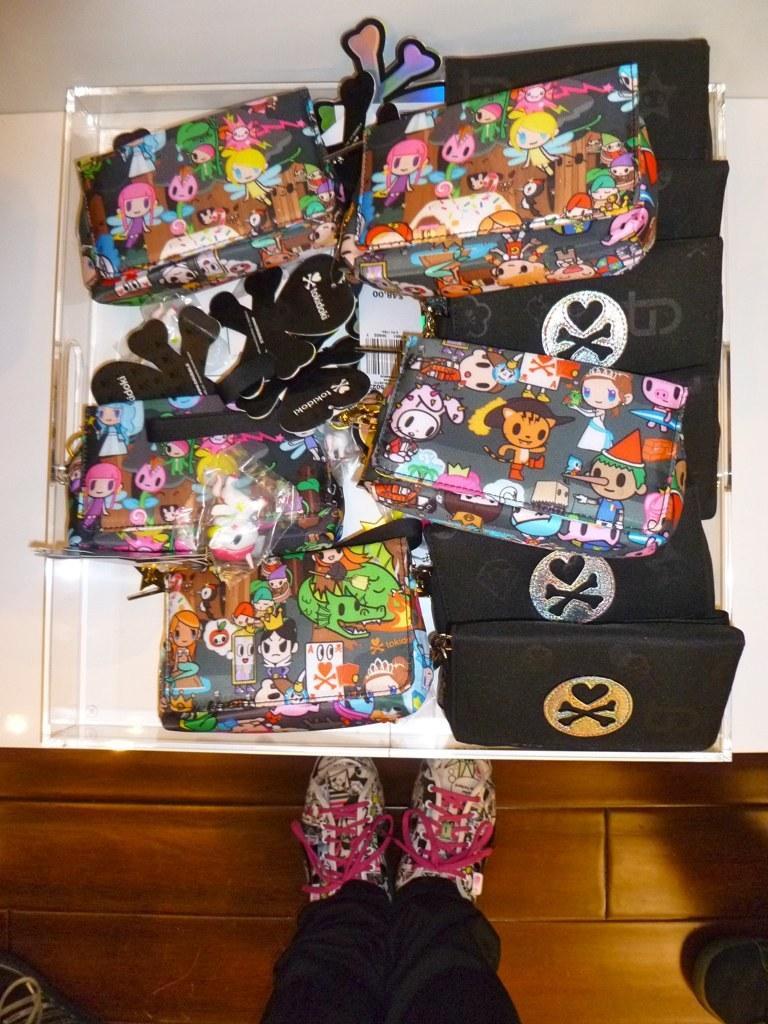Can you describe this image briefly? In the image we can see there is a tray in which purses and wallets are kept. Few purses are covered with cartoon stickers and others are of black colour. A person is standing, wearing shoes and the lace are of pink colour and the floor is brown colour. 